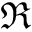<formula> <loc_0><loc_0><loc_500><loc_500>\Re</formula> 